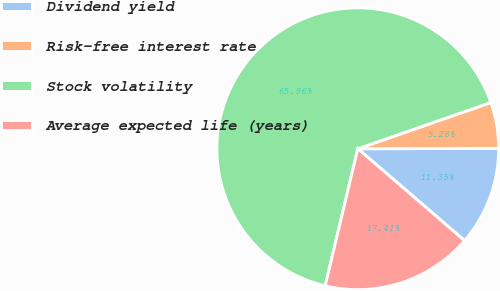Convert chart. <chart><loc_0><loc_0><loc_500><loc_500><pie_chart><fcel>Dividend yield<fcel>Risk-free interest rate<fcel>Stock volatility<fcel>Average expected life (years)<nl><fcel>11.35%<fcel>5.28%<fcel>65.96%<fcel>17.41%<nl></chart> 